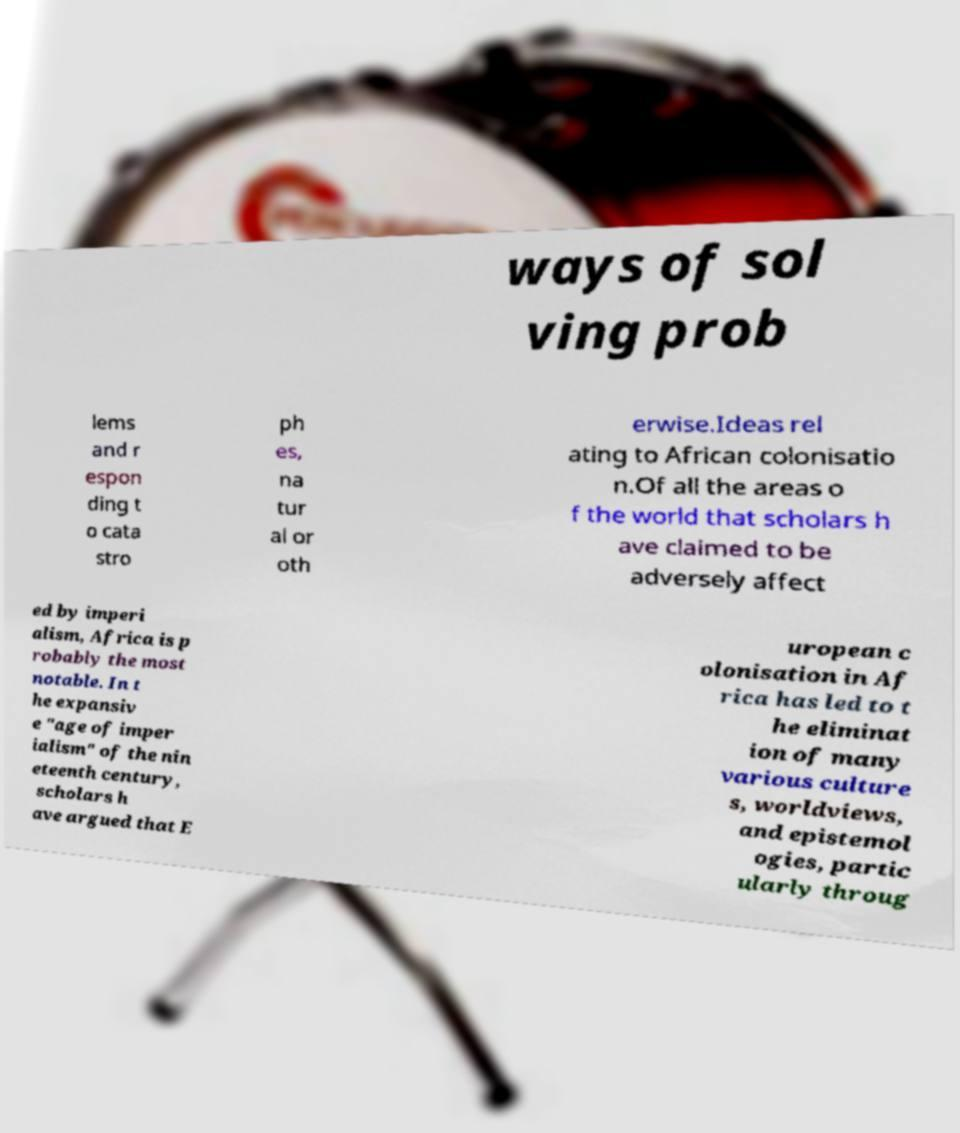What messages or text are displayed in this image? I need them in a readable, typed format. ways of sol ving prob lems and r espon ding t o cata stro ph es, na tur al or oth erwise.Ideas rel ating to African colonisatio n.Of all the areas o f the world that scholars h ave claimed to be adversely affect ed by imperi alism, Africa is p robably the most notable. In t he expansiv e "age of imper ialism" of the nin eteenth century, scholars h ave argued that E uropean c olonisation in Af rica has led to t he eliminat ion of many various culture s, worldviews, and epistemol ogies, partic ularly throug 